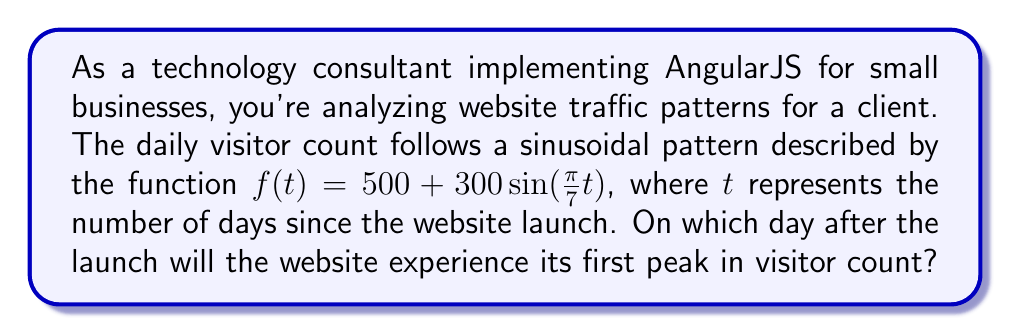Can you answer this question? To find the first peak in visitor count, we need to determine when the sine function reaches its maximum value. Let's approach this step-by-step:

1) The general form of a sine function is:
   $f(t) = A\sin(Bt) + C$
   where $A$ is the amplitude, $B$ is the angular frequency, and $C$ is the vertical shift.

2) In our function $f(t) = 500 + 300\sin(\frac{\pi}{7}t)$:
   $A = 300$ (amplitude)
   $B = \frac{\pi}{7}$ (angular frequency)
   $C = 500$ (vertical shift)

3) The sine function reaches its maximum value when its argument is $\frac{\pi}{2}$ (or 90 degrees).

4) So, we need to solve:
   $\frac{\pi}{7}t = \frac{\pi}{2}$

5) Solving for $t$:
   $t = \frac{\pi}{2} \cdot \frac{7}{\pi} = \frac{7}{2} = 3.5$

6) Since $t$ represents days, and we can't have a fractional day, we round up to the next whole number.

7) Therefore, the first peak will occur on day 4 after the launch.
Answer: 4 days 